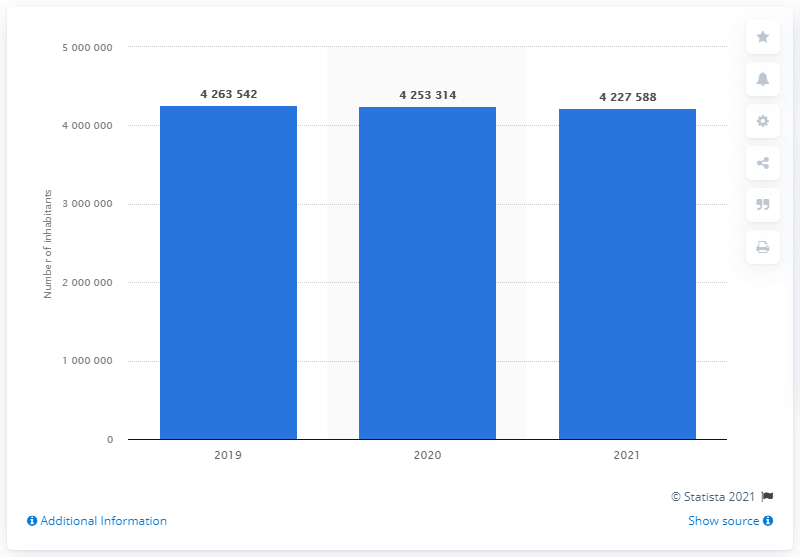Mention a couple of crucial points in this snapshot. As of January 2021, the population of the Italian province of Rome was approximately 4,227,588. 